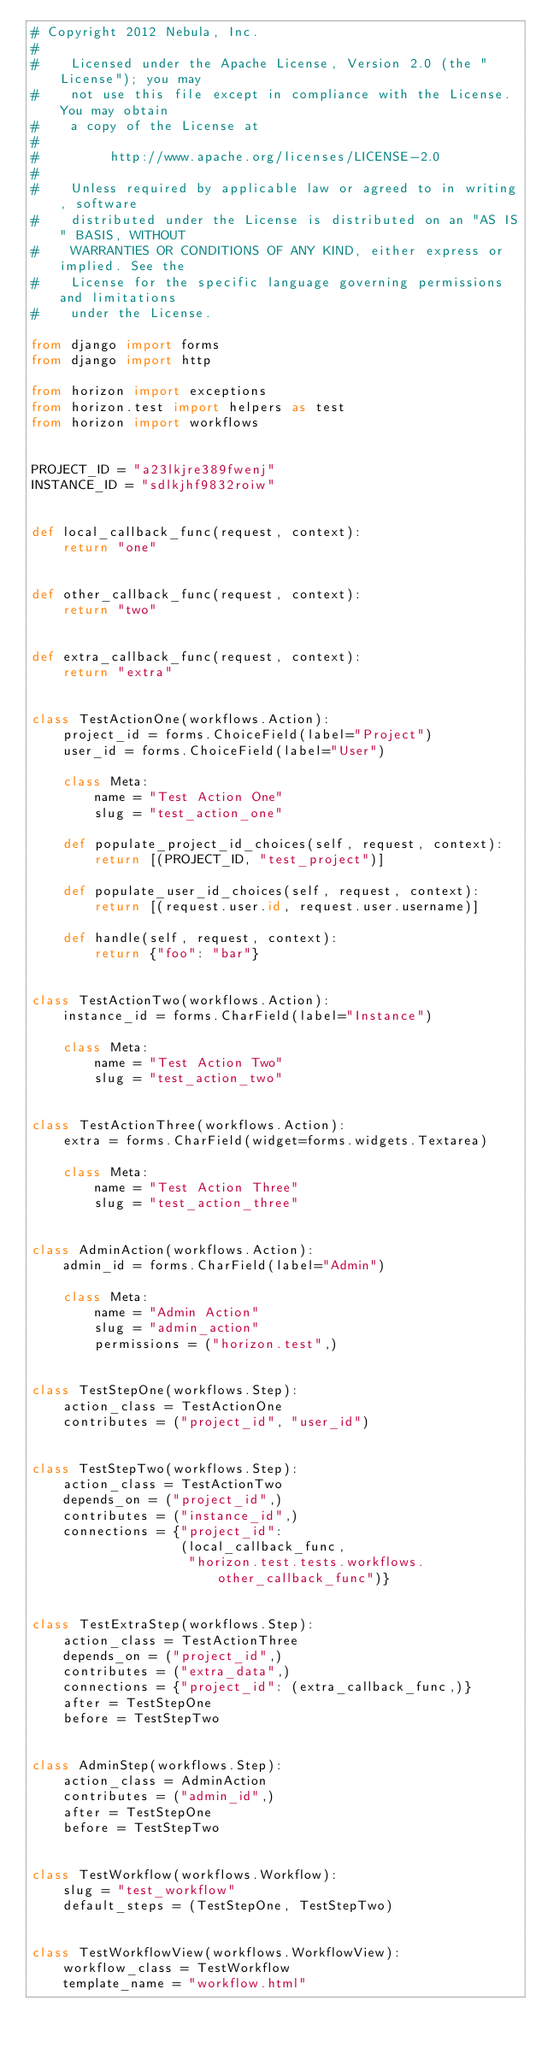<code> <loc_0><loc_0><loc_500><loc_500><_Python_># Copyright 2012 Nebula, Inc.
#
#    Licensed under the Apache License, Version 2.0 (the "License"); you may
#    not use this file except in compliance with the License. You may obtain
#    a copy of the License at
#
#         http://www.apache.org/licenses/LICENSE-2.0
#
#    Unless required by applicable law or agreed to in writing, software
#    distributed under the License is distributed on an "AS IS" BASIS, WITHOUT
#    WARRANTIES OR CONDITIONS OF ANY KIND, either express or implied. See the
#    License for the specific language governing permissions and limitations
#    under the License.

from django import forms
from django import http

from horizon import exceptions
from horizon.test import helpers as test
from horizon import workflows


PROJECT_ID = "a23lkjre389fwenj"
INSTANCE_ID = "sdlkjhf9832roiw"


def local_callback_func(request, context):
    return "one"


def other_callback_func(request, context):
    return "two"


def extra_callback_func(request, context):
    return "extra"


class TestActionOne(workflows.Action):
    project_id = forms.ChoiceField(label="Project")
    user_id = forms.ChoiceField(label="User")

    class Meta:
        name = "Test Action One"
        slug = "test_action_one"

    def populate_project_id_choices(self, request, context):
        return [(PROJECT_ID, "test_project")]

    def populate_user_id_choices(self, request, context):
        return [(request.user.id, request.user.username)]

    def handle(self, request, context):
        return {"foo": "bar"}


class TestActionTwo(workflows.Action):
    instance_id = forms.CharField(label="Instance")

    class Meta:
        name = "Test Action Two"
        slug = "test_action_two"


class TestActionThree(workflows.Action):
    extra = forms.CharField(widget=forms.widgets.Textarea)

    class Meta:
        name = "Test Action Three"
        slug = "test_action_three"


class AdminAction(workflows.Action):
    admin_id = forms.CharField(label="Admin")

    class Meta:
        name = "Admin Action"
        slug = "admin_action"
        permissions = ("horizon.test",)


class TestStepOne(workflows.Step):
    action_class = TestActionOne
    contributes = ("project_id", "user_id")


class TestStepTwo(workflows.Step):
    action_class = TestActionTwo
    depends_on = ("project_id",)
    contributes = ("instance_id",)
    connections = {"project_id":
                   (local_callback_func,
                    "horizon.test.tests.workflows.other_callback_func")}


class TestExtraStep(workflows.Step):
    action_class = TestActionThree
    depends_on = ("project_id",)
    contributes = ("extra_data",)
    connections = {"project_id": (extra_callback_func,)}
    after = TestStepOne
    before = TestStepTwo


class AdminStep(workflows.Step):
    action_class = AdminAction
    contributes = ("admin_id",)
    after = TestStepOne
    before = TestStepTwo


class TestWorkflow(workflows.Workflow):
    slug = "test_workflow"
    default_steps = (TestStepOne, TestStepTwo)


class TestWorkflowView(workflows.WorkflowView):
    workflow_class = TestWorkflow
    template_name = "workflow.html"

</code> 